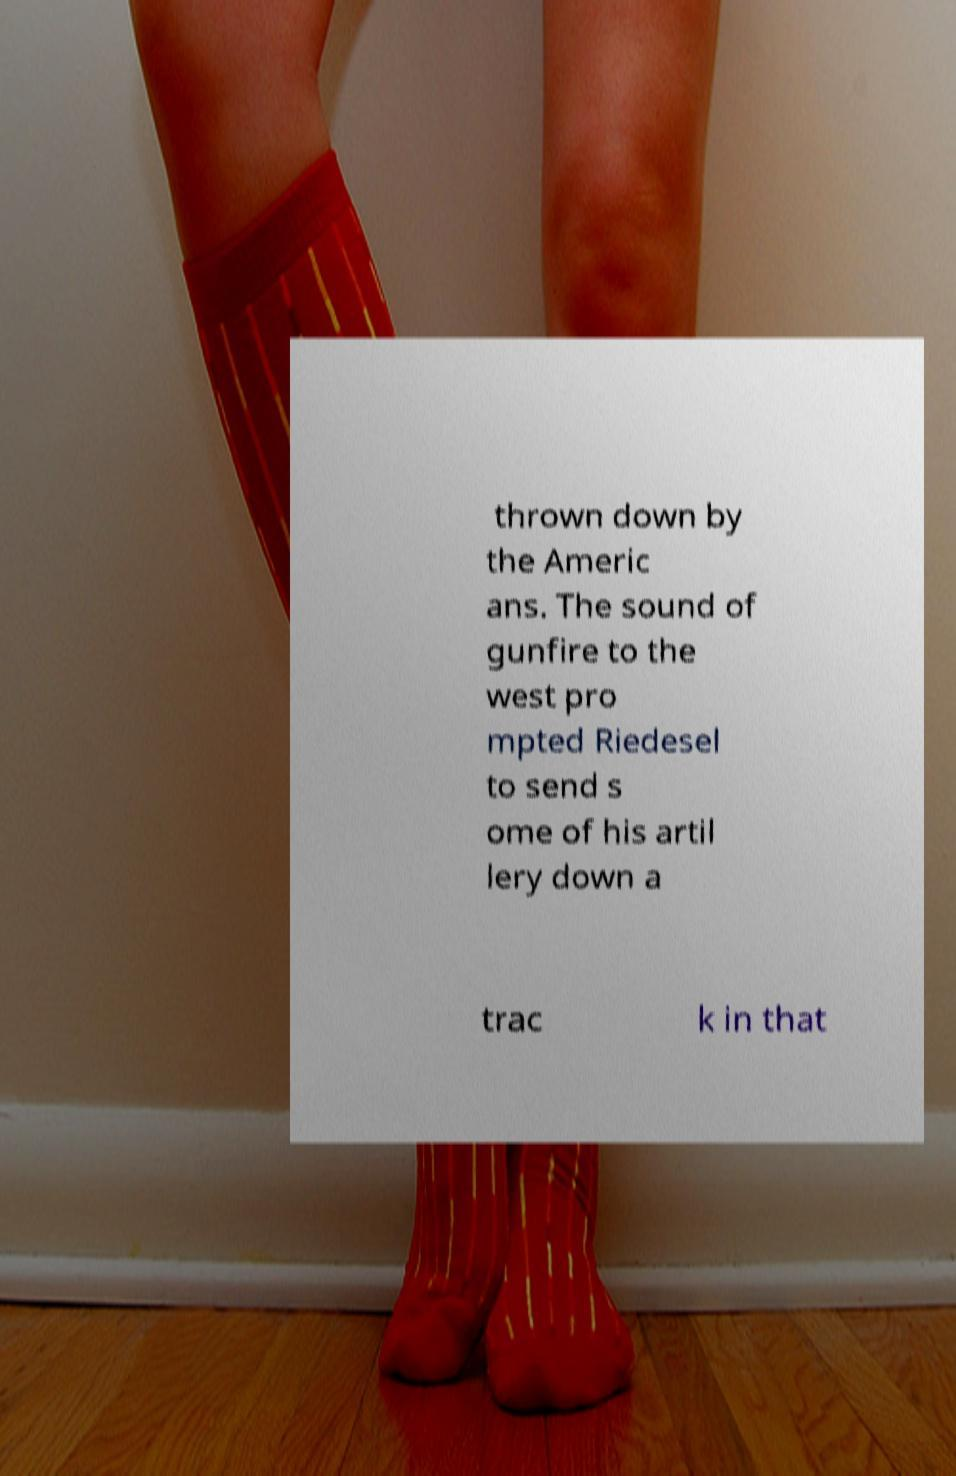Please identify and transcribe the text found in this image. thrown down by the Americ ans. The sound of gunfire to the west pro mpted Riedesel to send s ome of his artil lery down a trac k in that 